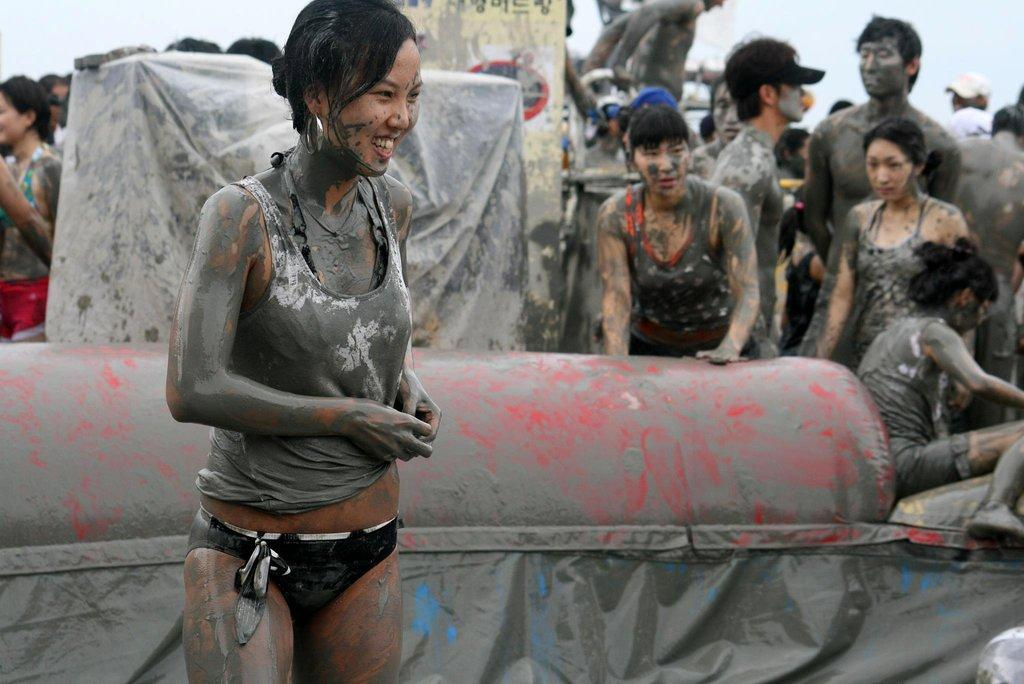Who is the main subject in the image? There is a woman in the image. What is the woman wearing? The woman is wearing a sweatshirt. What is the condition of the woman in the image? The woman has mud all over her. What can be seen in the background of the image? There are many people in the background of the image. What is the condition of the people in the background? The people in the background have mud all over them. What type of doll is being used by the maid in the image? There is no doll or maid present in the image. 